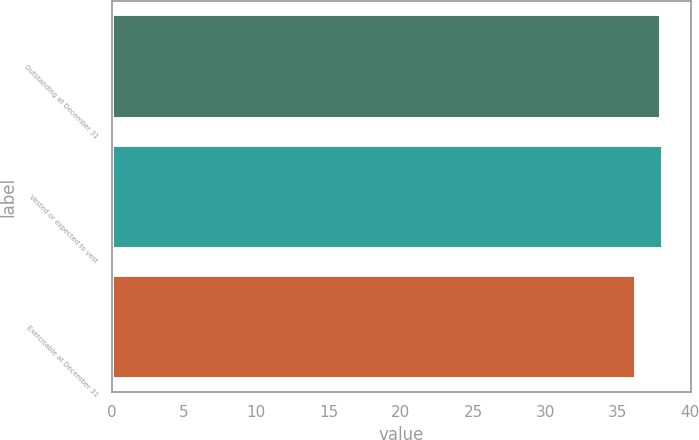Convert chart. <chart><loc_0><loc_0><loc_500><loc_500><bar_chart><fcel>Outstanding at December 31<fcel>Vested or expected to vest<fcel>Exercisable at December 31<nl><fcel>38.01<fcel>38.18<fcel>36.31<nl></chart> 